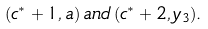Convert formula to latex. <formula><loc_0><loc_0><loc_500><loc_500>( c ^ { * } + 1 , a ) \, a n d \, ( c ^ { * } + 2 , y _ { 3 } ) .</formula> 